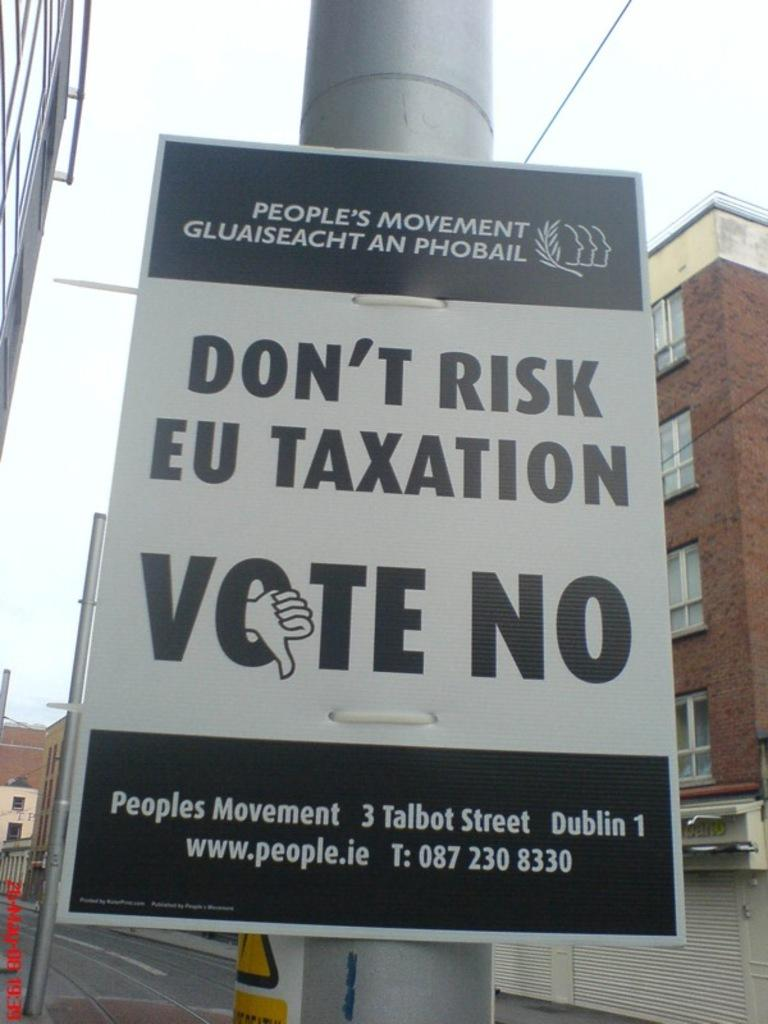<image>
Describe the image concisely. A black and white sign that reads dont risk eu taxation vote no. 